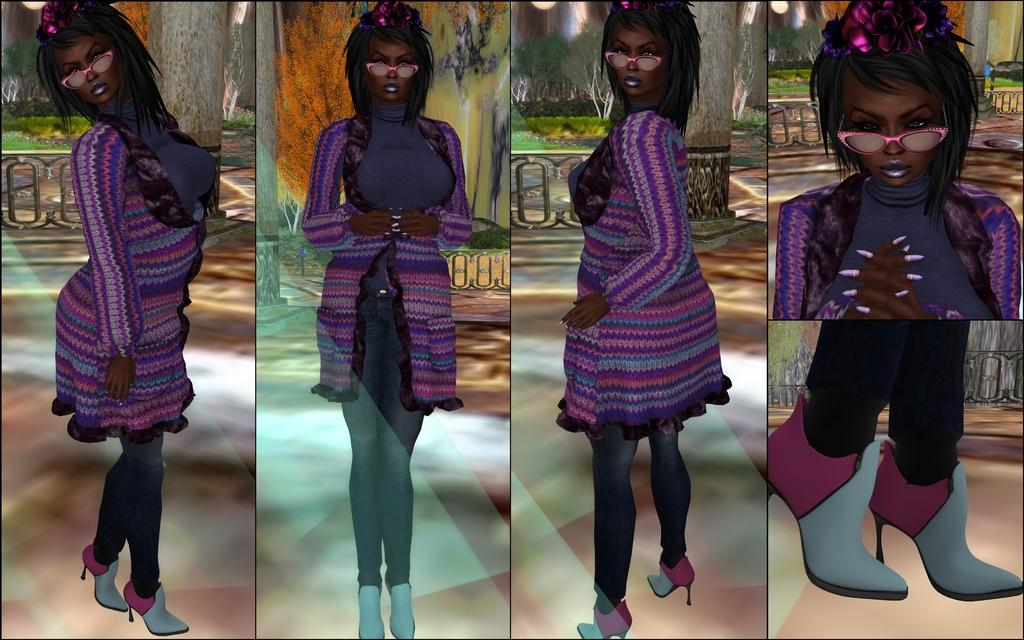What type of image is being described? The image is a collage of multiple pictures. Are there any recurring elements in the collage? Yes, the same woman appears in each picture of the collage. What can be seen in the background of some pictures in the collage? There is a painting of a plant in the background of at least one picture, and there is a tree trunk visible in the background of at least one picture. What is the income of the woman in the image? There is no information about the woman's income in the image. How does the fog affect the visibility of the images in the collage? There is no fog present in the image, so it does not affect the visibility of the pictures in the collage. 